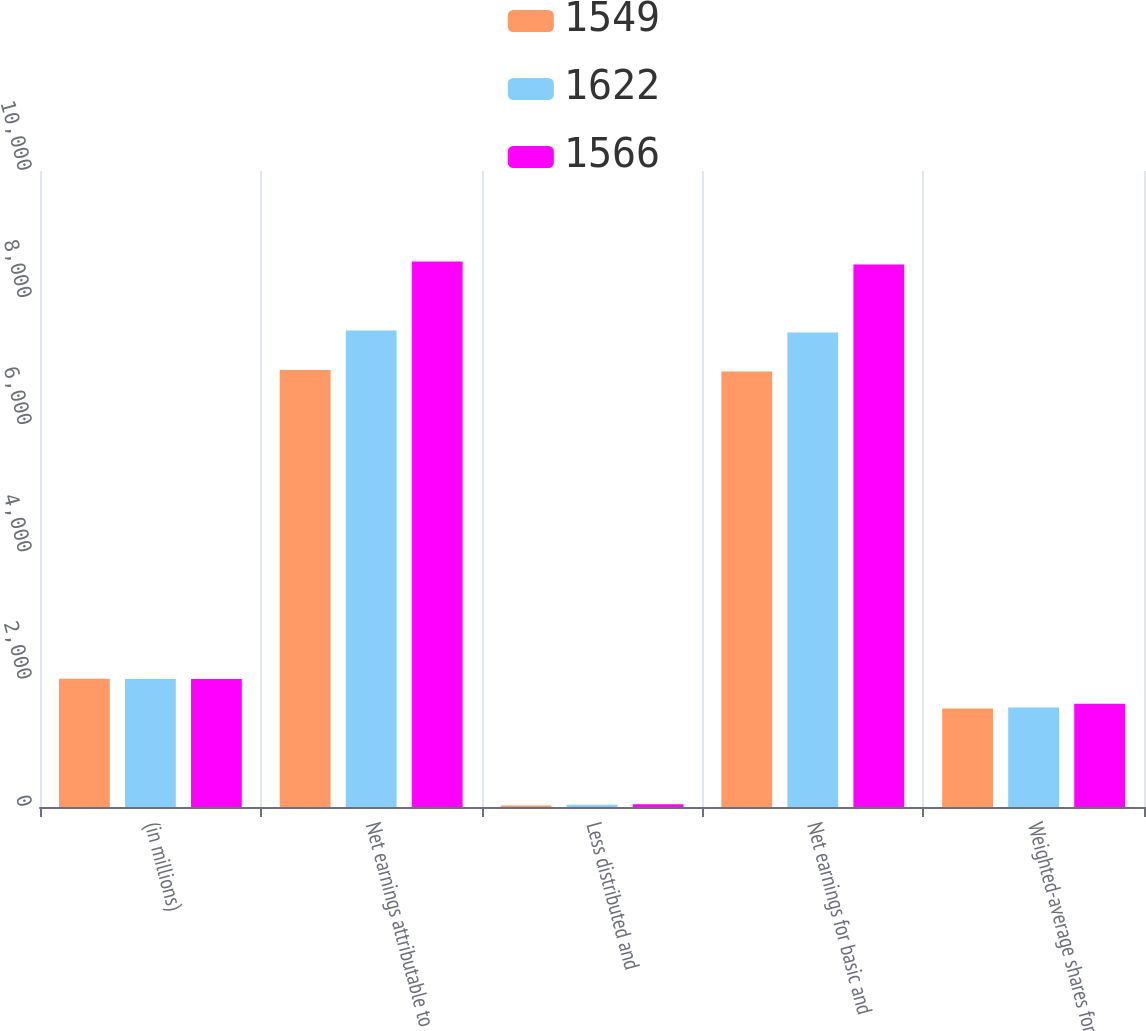<chart> <loc_0><loc_0><loc_500><loc_500><stacked_bar_chart><ecel><fcel>(in millions)<fcel>Net earnings attributable to<fcel>Less distributed and<fcel>Net earnings for basic and<fcel>Weighted-average shares for<nl><fcel>1549<fcel>2015<fcel>6873<fcel>24<fcel>6849<fcel>1549<nl><fcel>1622<fcel>2014<fcel>7493<fcel>34<fcel>7459<fcel>1566<nl><fcel>1566<fcel>2013<fcel>8576<fcel>45<fcel>8531<fcel>1622<nl></chart> 